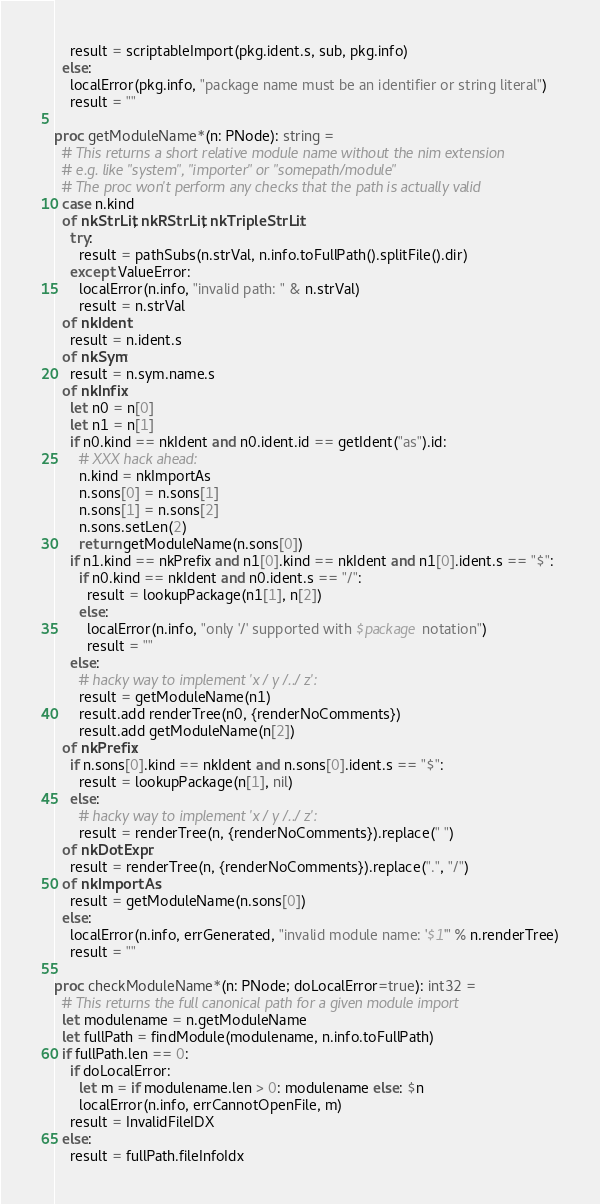Convert code to text. <code><loc_0><loc_0><loc_500><loc_500><_Nim_>    result = scriptableImport(pkg.ident.s, sub, pkg.info)
  else:
    localError(pkg.info, "package name must be an identifier or string literal")
    result = ""

proc getModuleName*(n: PNode): string =
  # This returns a short relative module name without the nim extension
  # e.g. like "system", "importer" or "somepath/module"
  # The proc won't perform any checks that the path is actually valid
  case n.kind
  of nkStrLit, nkRStrLit, nkTripleStrLit:
    try:
      result = pathSubs(n.strVal, n.info.toFullPath().splitFile().dir)
    except ValueError:
      localError(n.info, "invalid path: " & n.strVal)
      result = n.strVal
  of nkIdent:
    result = n.ident.s
  of nkSym:
    result = n.sym.name.s
  of nkInfix:
    let n0 = n[0]
    let n1 = n[1]
    if n0.kind == nkIdent and n0.ident.id == getIdent("as").id:
      # XXX hack ahead:
      n.kind = nkImportAs
      n.sons[0] = n.sons[1]
      n.sons[1] = n.sons[2]
      n.sons.setLen(2)
      return getModuleName(n.sons[0])
    if n1.kind == nkPrefix and n1[0].kind == nkIdent and n1[0].ident.s == "$":
      if n0.kind == nkIdent and n0.ident.s == "/":
        result = lookupPackage(n1[1], n[2])
      else:
        localError(n.info, "only '/' supported with $package notation")
        result = ""
    else:
      # hacky way to implement 'x / y /../ z':
      result = getModuleName(n1)
      result.add renderTree(n0, {renderNoComments})
      result.add getModuleName(n[2])
  of nkPrefix:
    if n.sons[0].kind == nkIdent and n.sons[0].ident.s == "$":
      result = lookupPackage(n[1], nil)
    else:
      # hacky way to implement 'x / y /../ z':
      result = renderTree(n, {renderNoComments}).replace(" ")
  of nkDotExpr:
    result = renderTree(n, {renderNoComments}).replace(".", "/")
  of nkImportAs:
    result = getModuleName(n.sons[0])
  else:
    localError(n.info, errGenerated, "invalid module name: '$1'" % n.renderTree)
    result = ""

proc checkModuleName*(n: PNode; doLocalError=true): int32 =
  # This returns the full canonical path for a given module import
  let modulename = n.getModuleName
  let fullPath = findModule(modulename, n.info.toFullPath)
  if fullPath.len == 0:
    if doLocalError:
      let m = if modulename.len > 0: modulename else: $n
      localError(n.info, errCannotOpenFile, m)
    result = InvalidFileIDX
  else:
    result = fullPath.fileInfoIdx
</code> 